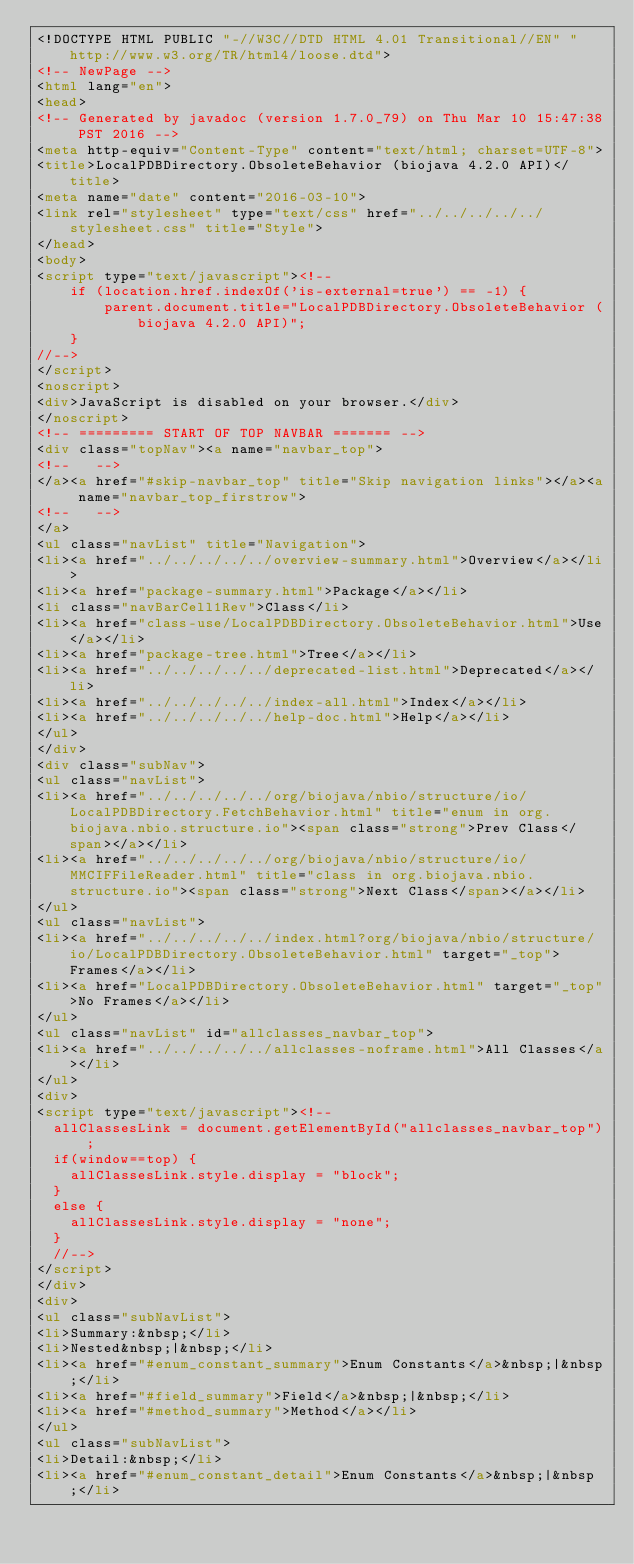<code> <loc_0><loc_0><loc_500><loc_500><_HTML_><!DOCTYPE HTML PUBLIC "-//W3C//DTD HTML 4.01 Transitional//EN" "http://www.w3.org/TR/html4/loose.dtd">
<!-- NewPage -->
<html lang="en">
<head>
<!-- Generated by javadoc (version 1.7.0_79) on Thu Mar 10 15:47:38 PST 2016 -->
<meta http-equiv="Content-Type" content="text/html; charset=UTF-8">
<title>LocalPDBDirectory.ObsoleteBehavior (biojava 4.2.0 API)</title>
<meta name="date" content="2016-03-10">
<link rel="stylesheet" type="text/css" href="../../../../../stylesheet.css" title="Style">
</head>
<body>
<script type="text/javascript"><!--
    if (location.href.indexOf('is-external=true') == -1) {
        parent.document.title="LocalPDBDirectory.ObsoleteBehavior (biojava 4.2.0 API)";
    }
//-->
</script>
<noscript>
<div>JavaScript is disabled on your browser.</div>
</noscript>
<!-- ========= START OF TOP NAVBAR ======= -->
<div class="topNav"><a name="navbar_top">
<!--   -->
</a><a href="#skip-navbar_top" title="Skip navigation links"></a><a name="navbar_top_firstrow">
<!--   -->
</a>
<ul class="navList" title="Navigation">
<li><a href="../../../../../overview-summary.html">Overview</a></li>
<li><a href="package-summary.html">Package</a></li>
<li class="navBarCell1Rev">Class</li>
<li><a href="class-use/LocalPDBDirectory.ObsoleteBehavior.html">Use</a></li>
<li><a href="package-tree.html">Tree</a></li>
<li><a href="../../../../../deprecated-list.html">Deprecated</a></li>
<li><a href="../../../../../index-all.html">Index</a></li>
<li><a href="../../../../../help-doc.html">Help</a></li>
</ul>
</div>
<div class="subNav">
<ul class="navList">
<li><a href="../../../../../org/biojava/nbio/structure/io/LocalPDBDirectory.FetchBehavior.html" title="enum in org.biojava.nbio.structure.io"><span class="strong">Prev Class</span></a></li>
<li><a href="../../../../../org/biojava/nbio/structure/io/MMCIFFileReader.html" title="class in org.biojava.nbio.structure.io"><span class="strong">Next Class</span></a></li>
</ul>
<ul class="navList">
<li><a href="../../../../../index.html?org/biojava/nbio/structure/io/LocalPDBDirectory.ObsoleteBehavior.html" target="_top">Frames</a></li>
<li><a href="LocalPDBDirectory.ObsoleteBehavior.html" target="_top">No Frames</a></li>
</ul>
<ul class="navList" id="allclasses_navbar_top">
<li><a href="../../../../../allclasses-noframe.html">All Classes</a></li>
</ul>
<div>
<script type="text/javascript"><!--
  allClassesLink = document.getElementById("allclasses_navbar_top");
  if(window==top) {
    allClassesLink.style.display = "block";
  }
  else {
    allClassesLink.style.display = "none";
  }
  //-->
</script>
</div>
<div>
<ul class="subNavList">
<li>Summary:&nbsp;</li>
<li>Nested&nbsp;|&nbsp;</li>
<li><a href="#enum_constant_summary">Enum Constants</a>&nbsp;|&nbsp;</li>
<li><a href="#field_summary">Field</a>&nbsp;|&nbsp;</li>
<li><a href="#method_summary">Method</a></li>
</ul>
<ul class="subNavList">
<li>Detail:&nbsp;</li>
<li><a href="#enum_constant_detail">Enum Constants</a>&nbsp;|&nbsp;</li></code> 